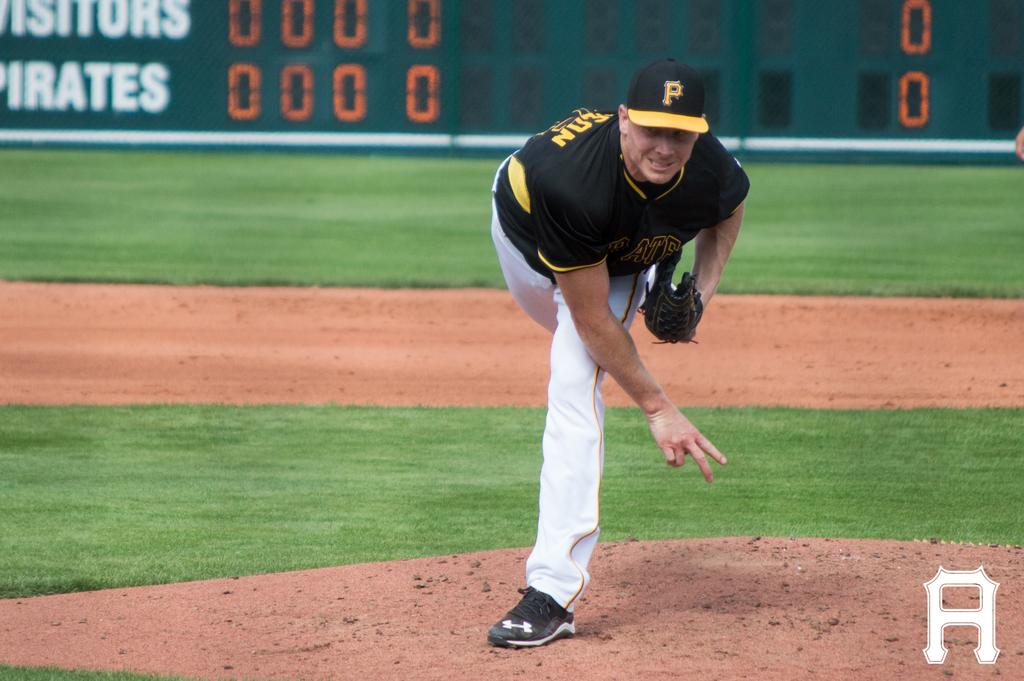What team is listed on the bottom of the scoreboard?
Give a very brief answer. Pirates. What letter is printed on the cap of this baseball player?
Your response must be concise. P. 